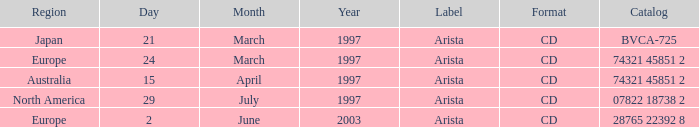What's the Date with the Region of Europe and has a Catalog of 28765 22392 8? 2 June 2003. 